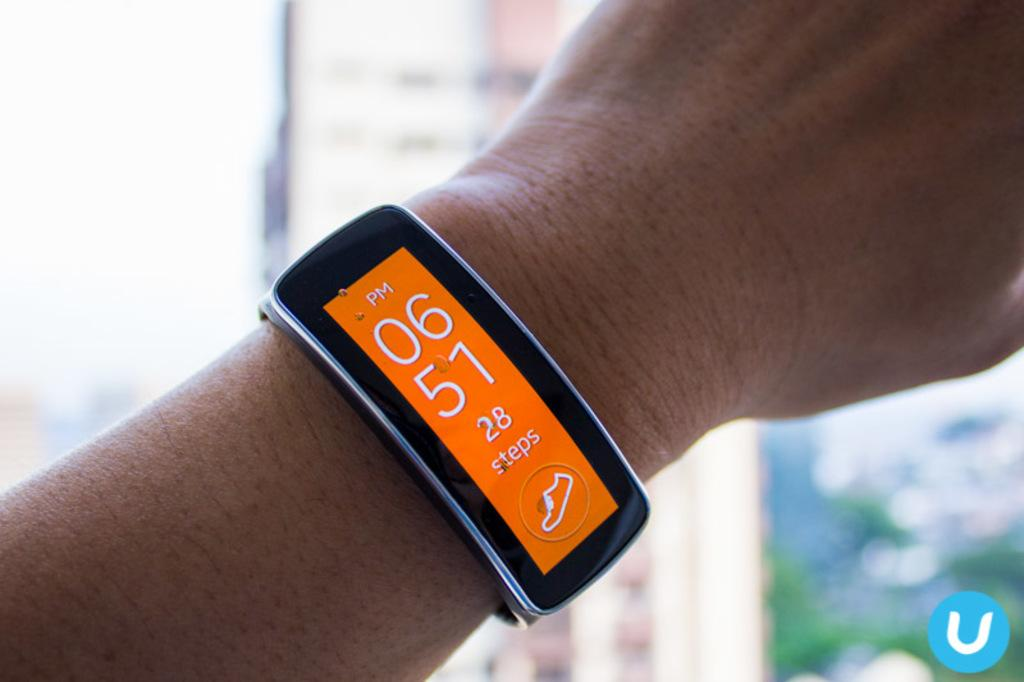<image>
Summarize the visual content of the image. A digital watch displays that 28 steps have been taken, along with the time of 6:15 PM. 